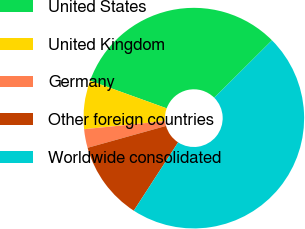<chart> <loc_0><loc_0><loc_500><loc_500><pie_chart><fcel>United States<fcel>United Kingdom<fcel>Germany<fcel>Other foreign countries<fcel>Worldwide consolidated<nl><fcel>32.02%<fcel>7.12%<fcel>2.73%<fcel>11.51%<fcel>46.63%<nl></chart> 